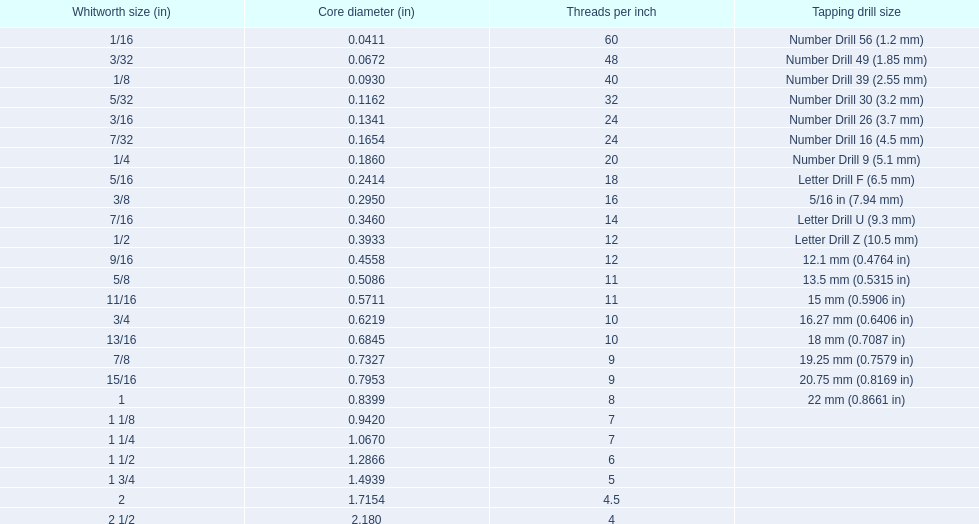What was the core diameter of a number drill 26 0.1341. What is this measurement in whitworth size? 3/16. 